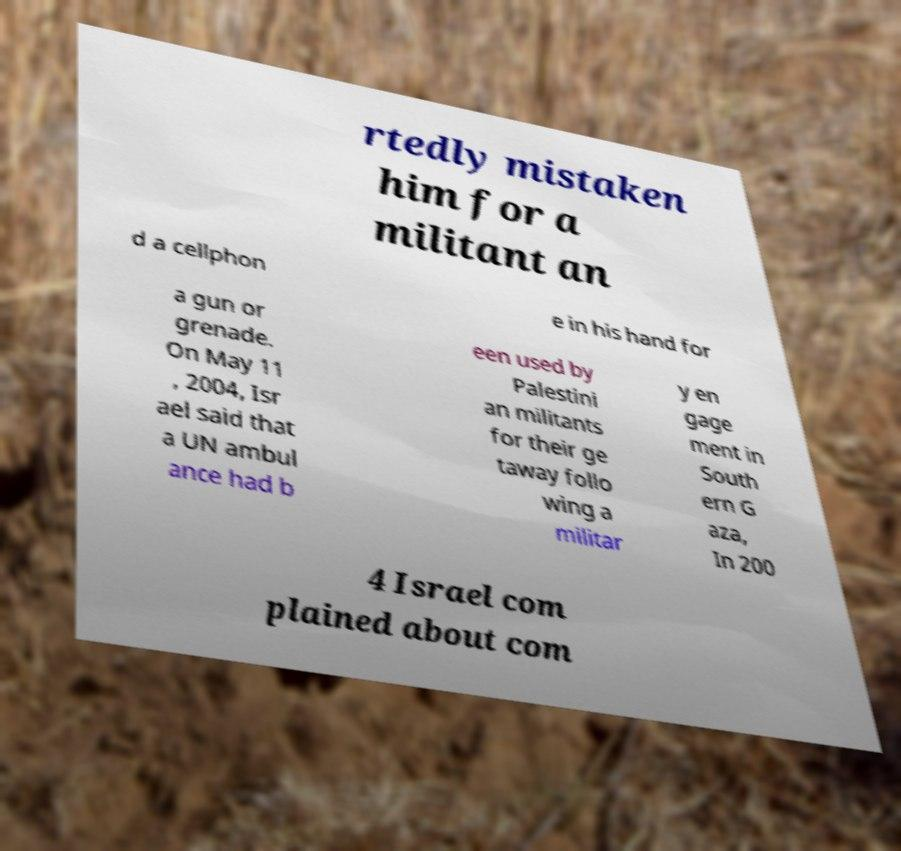For documentation purposes, I need the text within this image transcribed. Could you provide that? rtedly mistaken him for a militant an d a cellphon e in his hand for a gun or grenade. On May 11 , 2004, Isr ael said that a UN ambul ance had b een used by Palestini an militants for their ge taway follo wing a militar y en gage ment in South ern G aza, In 200 4 Israel com plained about com 